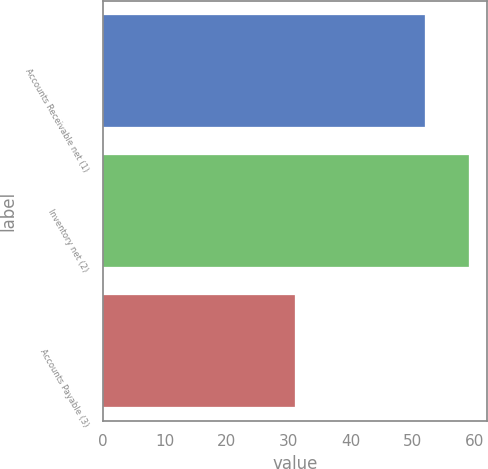Convert chart to OTSL. <chart><loc_0><loc_0><loc_500><loc_500><bar_chart><fcel>Accounts Receivable net (1)<fcel>Inventory net (2)<fcel>Accounts Payable (3)<nl><fcel>52<fcel>59<fcel>31<nl></chart> 